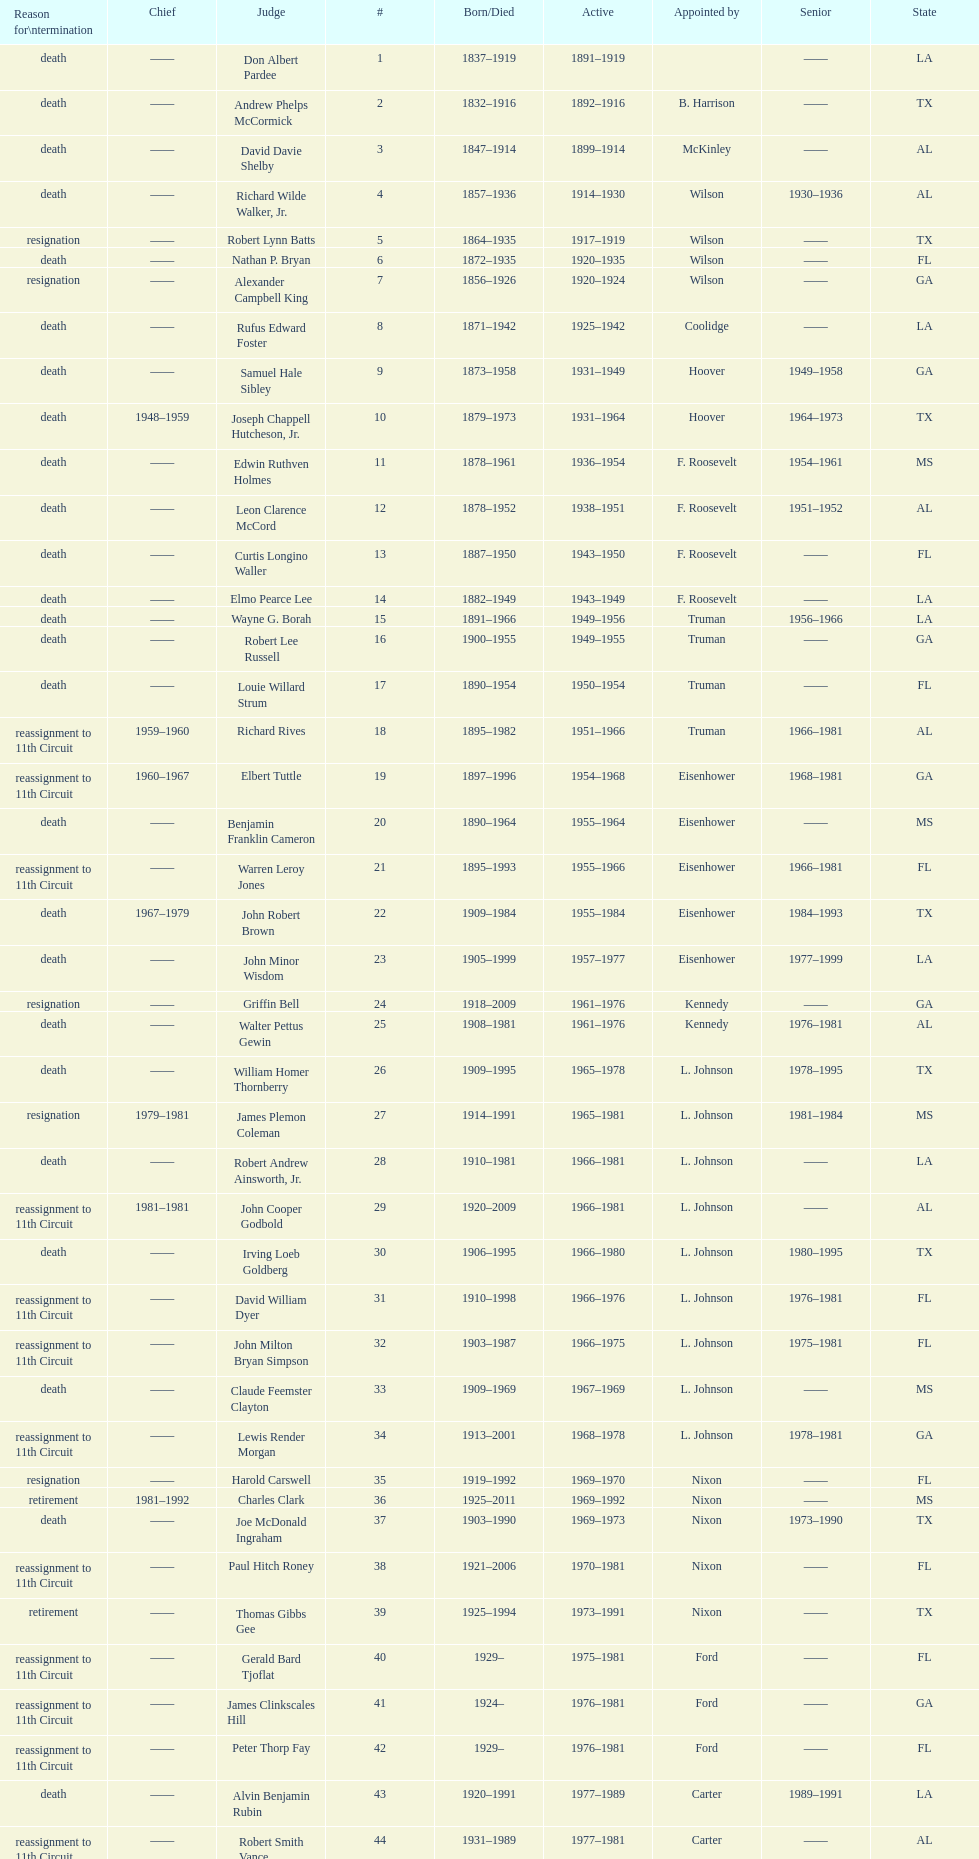Who was the next judge to resign after alexander campbell king? Griffin Bell. 